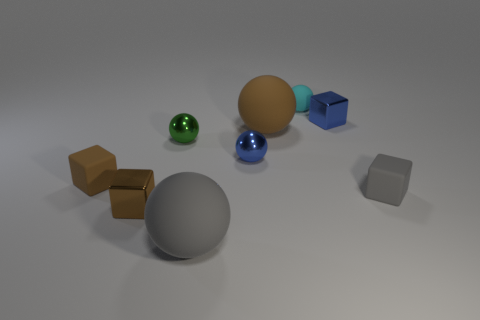Subtract all blue spheres. How many spheres are left? 4 Subtract 1 blocks. How many blocks are left? 3 Subtract all tiny rubber balls. How many balls are left? 4 Subtract all yellow balls. Subtract all brown cylinders. How many balls are left? 5 Subtract all blocks. How many objects are left? 5 Subtract 1 gray spheres. How many objects are left? 8 Subtract all tiny green metal objects. Subtract all big gray shiny blocks. How many objects are left? 8 Add 2 cyan rubber balls. How many cyan rubber balls are left? 3 Add 1 tiny cyan rubber cubes. How many tiny cyan rubber cubes exist? 1 